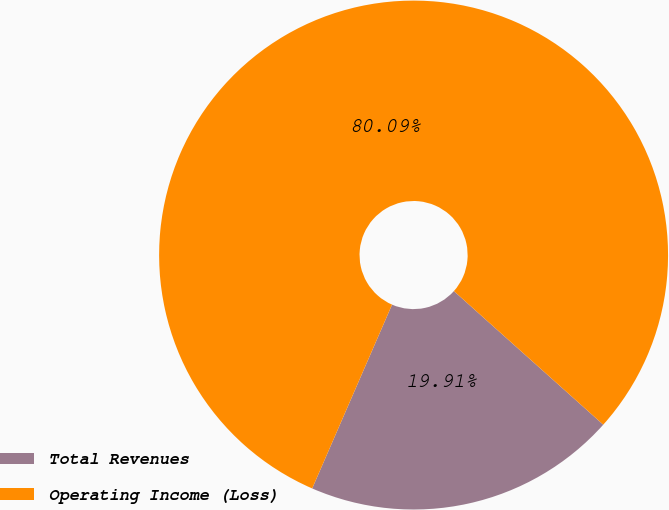Convert chart to OTSL. <chart><loc_0><loc_0><loc_500><loc_500><pie_chart><fcel>Total Revenues<fcel>Operating Income (Loss)<nl><fcel>19.91%<fcel>80.09%<nl></chart> 